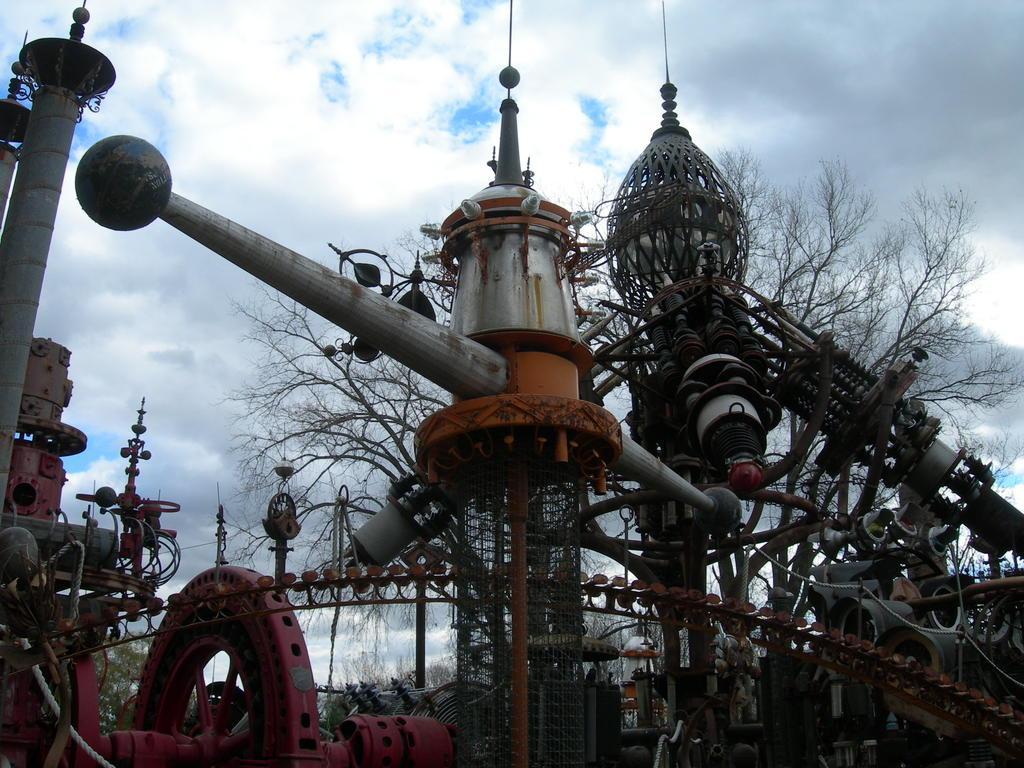Can you describe this image briefly? In this image there are metal objects. Background there are trees. Top of the image there is sky, having clouds. 